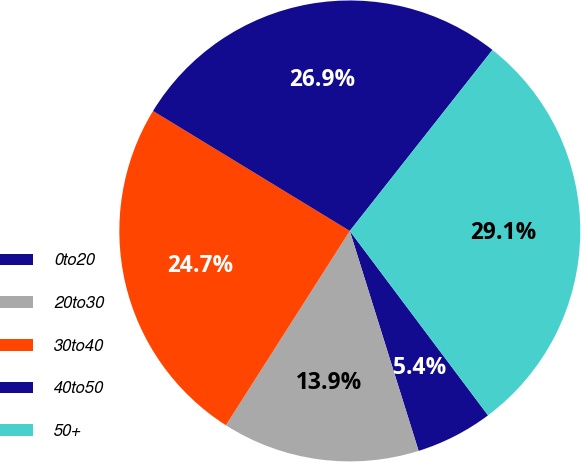Convert chart to OTSL. <chart><loc_0><loc_0><loc_500><loc_500><pie_chart><fcel>0to20<fcel>20to30<fcel>30to40<fcel>40to50<fcel>50+<nl><fcel>5.41%<fcel>13.86%<fcel>24.68%<fcel>26.91%<fcel>29.14%<nl></chart> 